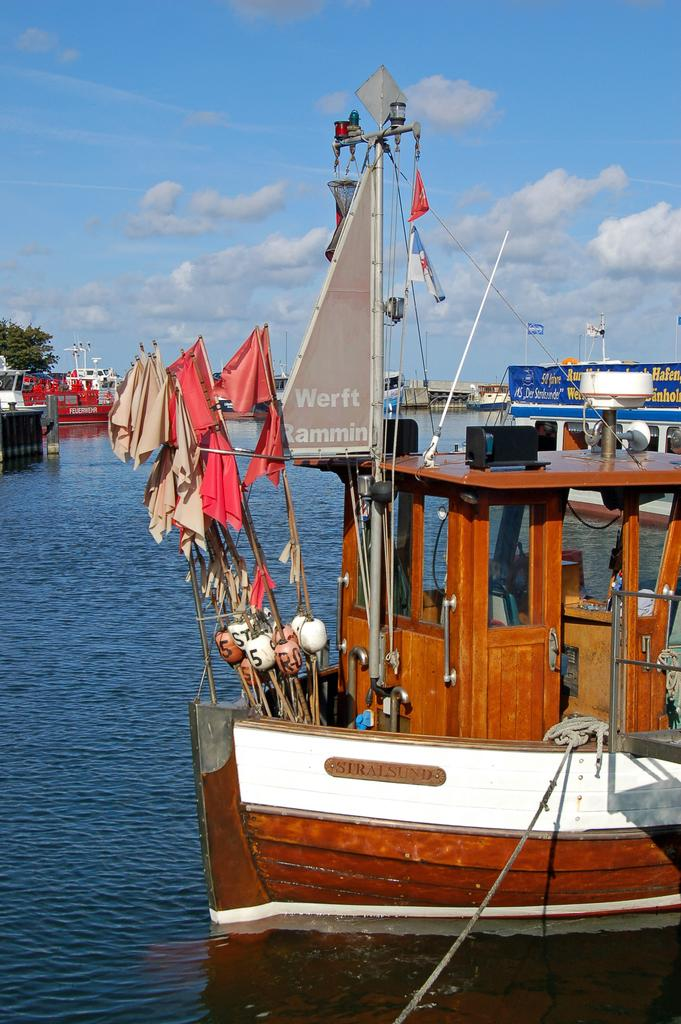<image>
Render a clear and concise summary of the photo. A boat iwith orange and white fabric on poles with a sign that says Werft Rammin is docked so it won't float away. 